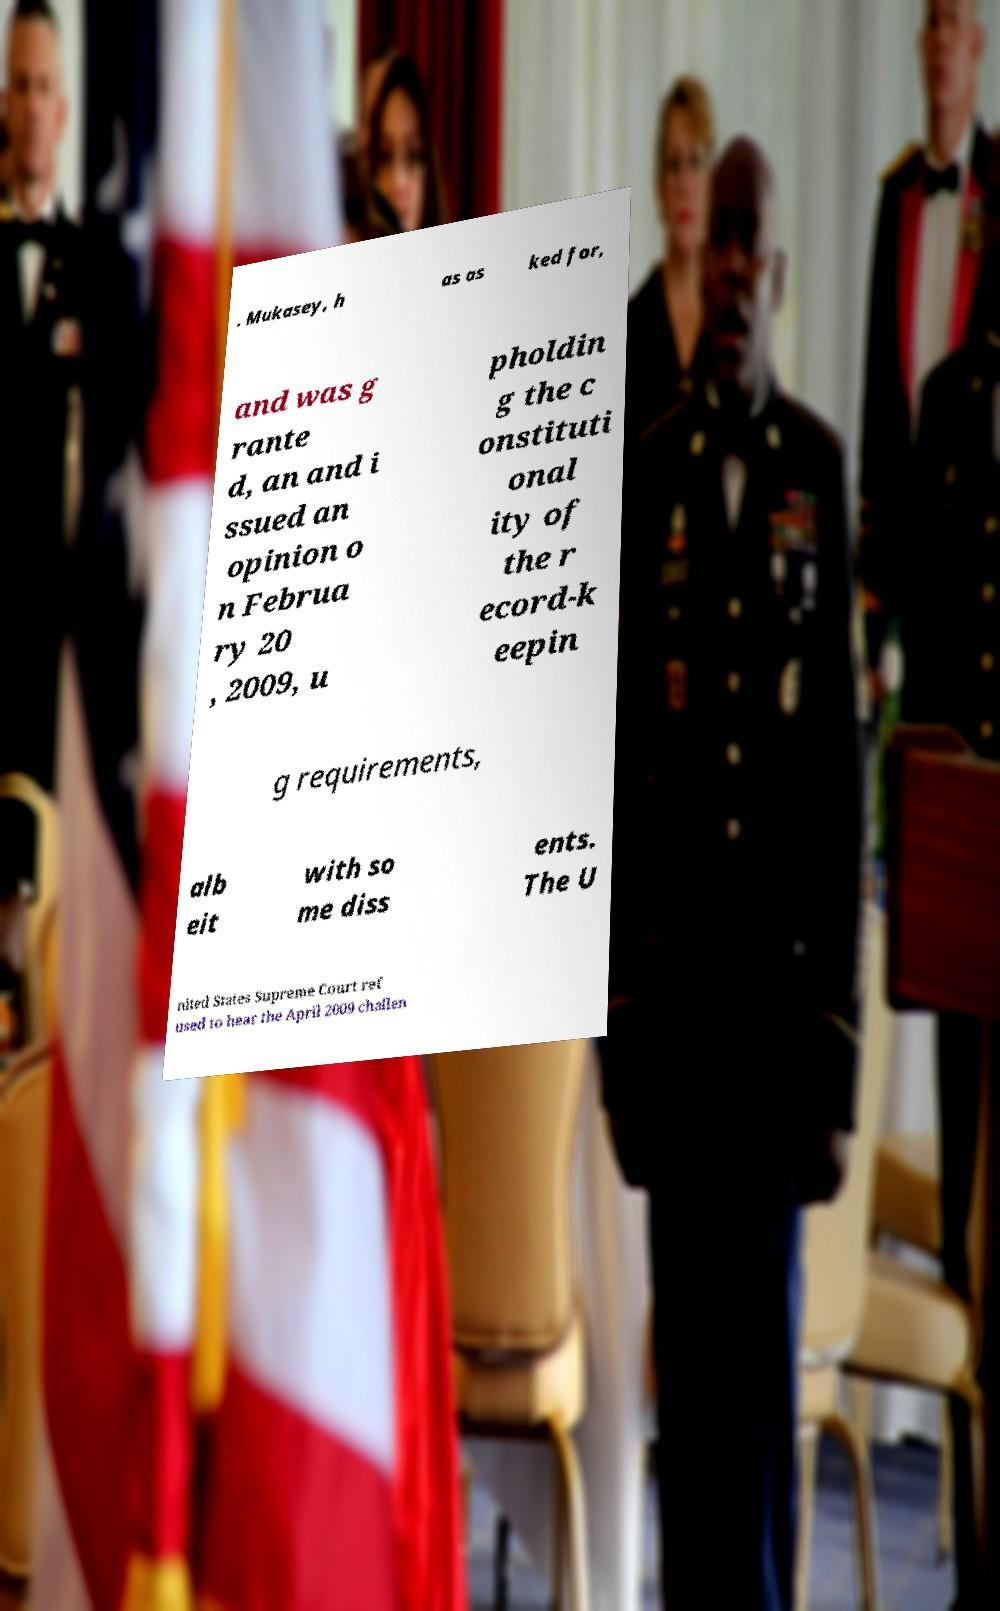Can you read and provide the text displayed in the image?This photo seems to have some interesting text. Can you extract and type it out for me? . Mukasey, h as as ked for, and was g rante d, an and i ssued an opinion o n Februa ry 20 , 2009, u pholdin g the c onstituti onal ity of the r ecord-k eepin g requirements, alb eit with so me diss ents. The U nited States Supreme Court ref used to hear the April 2009 challen 